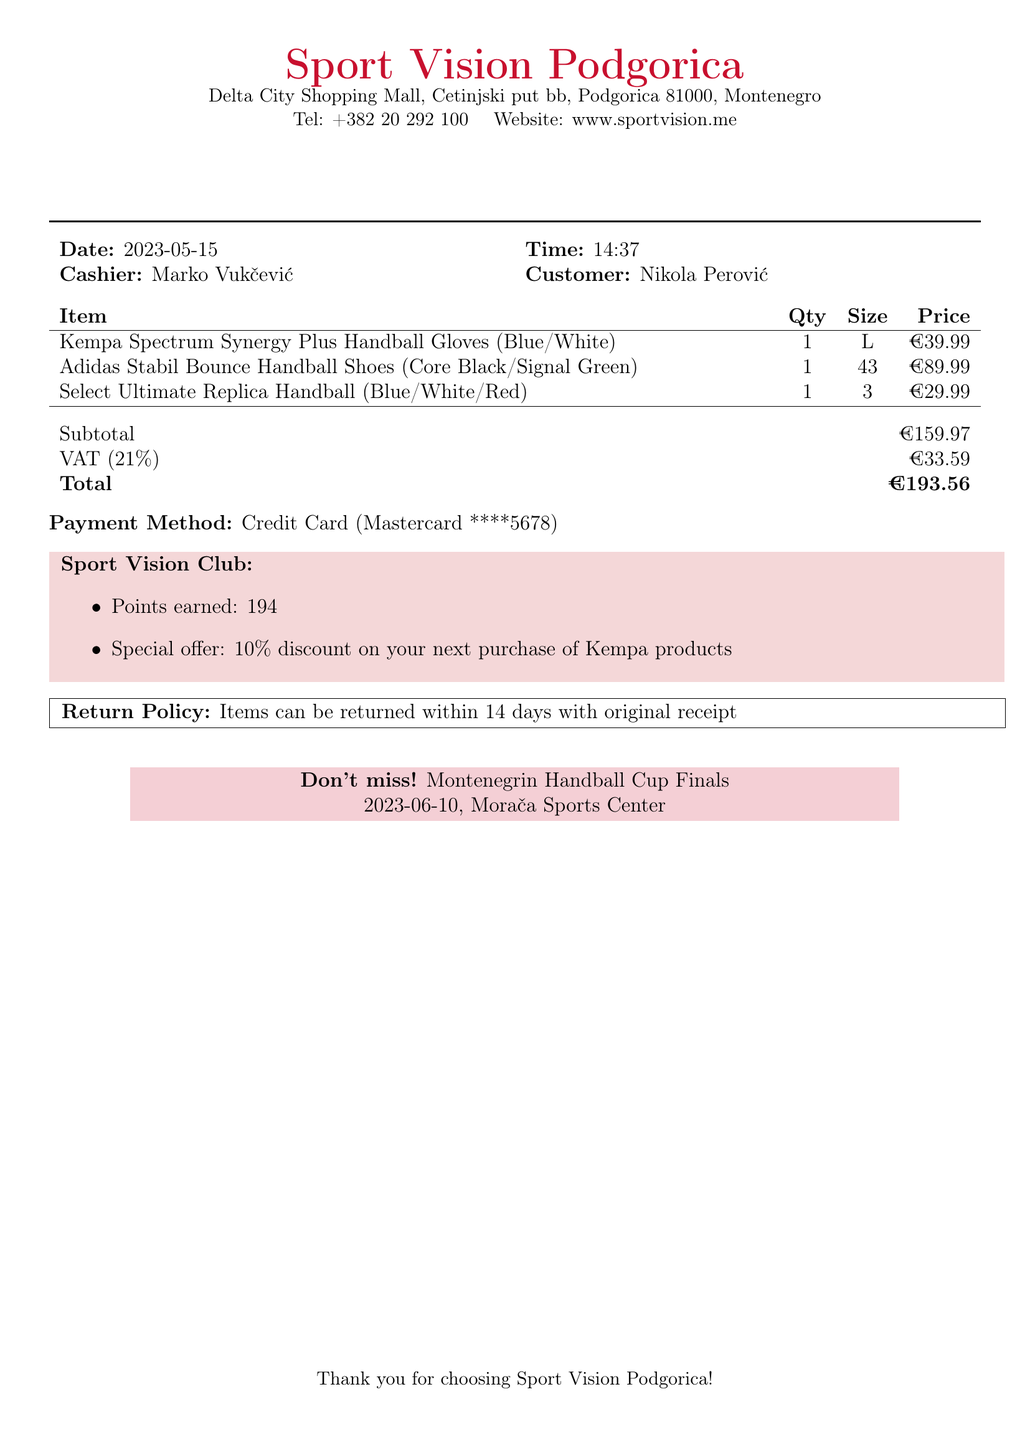What is the store name? The store name is prominently displayed at the top of the document.
Answer: Sport Vision Podgorica What is the total amount? The total amount is clearly stated in the transaction summary section.
Answer: €193.56 Who is the cashier? The cashier's name is mentioned in the customer information section.
Answer: Marko Vukčević What is the size of the handball gloves? The size of the gloves is mentioned in the item details.
Answer: L What is the VAT rate? The VAT rate can be found in the transaction summary section.
Answer: 21% How many loyalty points were earned? The loyalty points earned are listed in the loyalty program section.
Answer: 194 What is the payment method? The payment method is specified in the payment details section of the document.
Answer: Credit Card What is the special offer? The special offer is mentioned under the loyalty program section.
Answer: 10% discount on your next purchase of Kempa products When is the next handball event? The date and event are highlighted in the event announcement section.
Answer: 2023-06-10, Morača Sports Center 